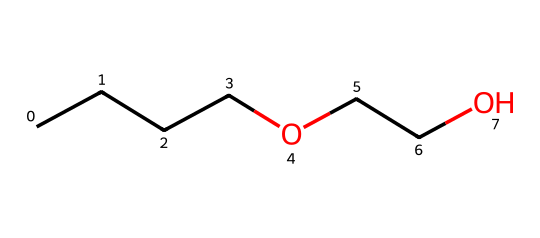What is the total number of carbon atoms in this ether compound? Analyzing the SMILES representation, CCCC represents four carbon atoms and each OCC represents two more carbon atoms, giving a total of six carbon atoms.
Answer: six How many ether linkages are present in this molecule? The structure contains one ether linkage, which is characterized by the oxygen atom connecting two carbon chains. This can be seen as the two carbon branches connected by the oxygen.
Answer: one What is the molecular formula for this ether compound? Counting the atoms in the structure, there are 6 carbon (C), 14 hydrogen (H), and 2 oxygen (O) atoms. This gives the molecular formula C6H14O2.
Answer: C6H14O2 What functional group is represented in this compound? The presence of an oxygen atom that connects carbon chains indicates the ether functional group, which is distinct from other functional groups such as alcohols or esters.
Answer: ether Does this ether have a linear or branched structure? Looking at the structure represented in the SMILES, the chains are straight without any branching, indicating a linear arrangement.
Answer: linear 